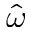Convert formula to latex. <formula><loc_0><loc_0><loc_500><loc_500>\hat { \omega }</formula> 